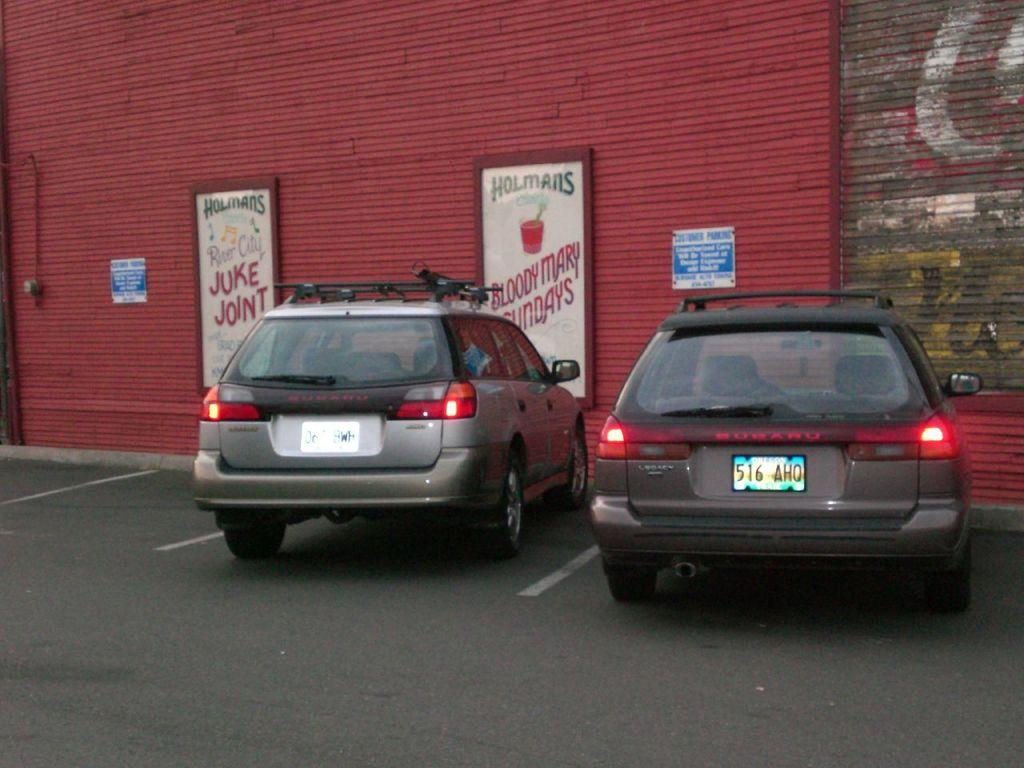Provide a one-sentence caption for the provided image. Two cars are parked next to a red building that has signs for Holmans. 